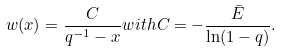Convert formula to latex. <formula><loc_0><loc_0><loc_500><loc_500>w ( x ) = \frac { C } { q ^ { - 1 } - x } w i t h C = - \frac { \bar { E } } { \ln ( 1 - q ) } .</formula> 